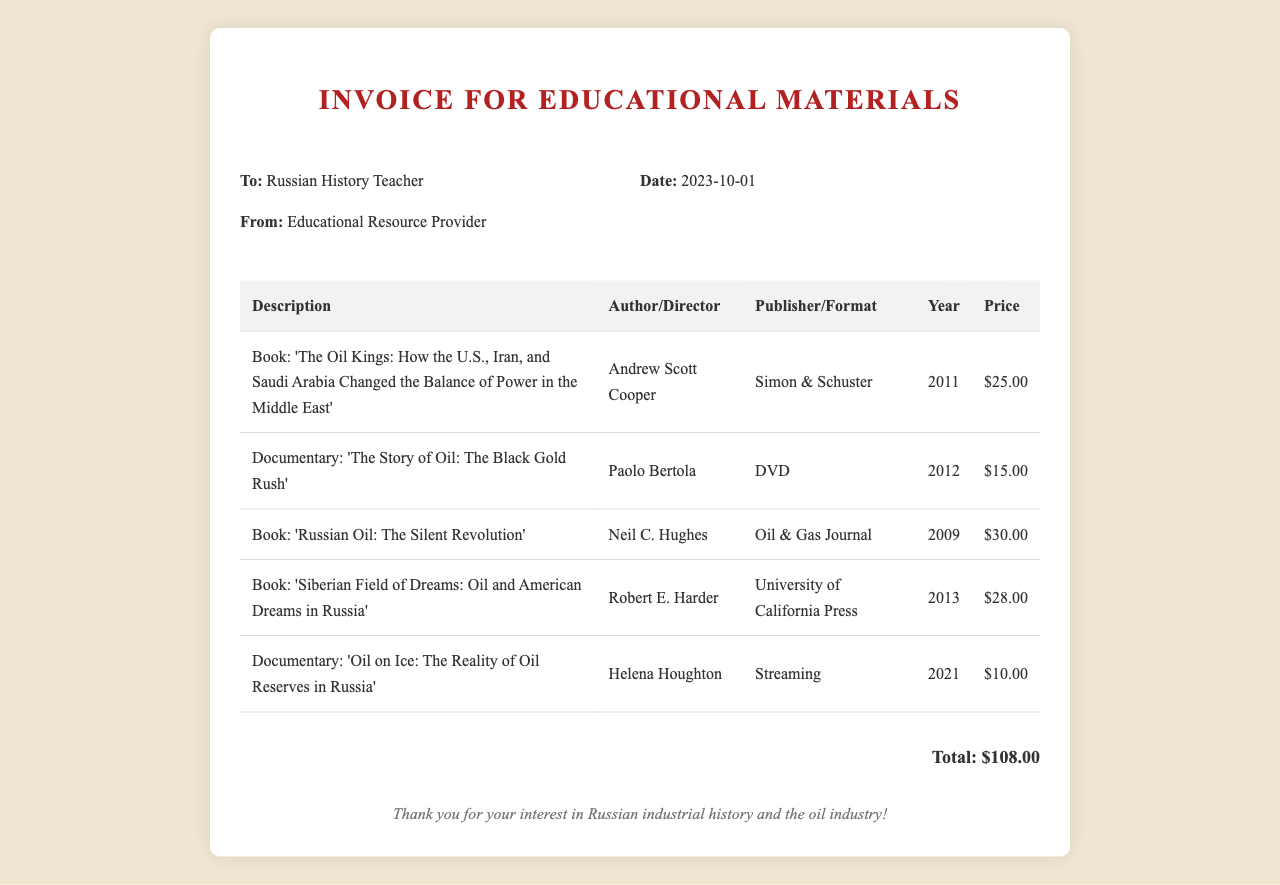What is the total amount for the invoice? The total amount is specified at the end of the invoice.
Answer: $108.00 Who is the author of "Russian Oil: The Silent Revolution"? This information is found in the table under the author column for the specified book.
Answer: Neil C. Hughes What format is the documentary "Oil on Ice: The Reality of Oil Reserves in Russia"? The format for this documentary is listed in the publisher/format column of the table.
Answer: Streaming Which book was published by Simon & Schuster? This requires identifying the publisher associated with a specific book in the document.
Answer: The Oil Kings: How the U.S., Iran, and Saudi Arabia Changed the Balance of Power in the Middle East Who is the recipient of the invoice? The recipient's name is mentioned at the beginning of the invoice details section.
Answer: Russian History Teacher 